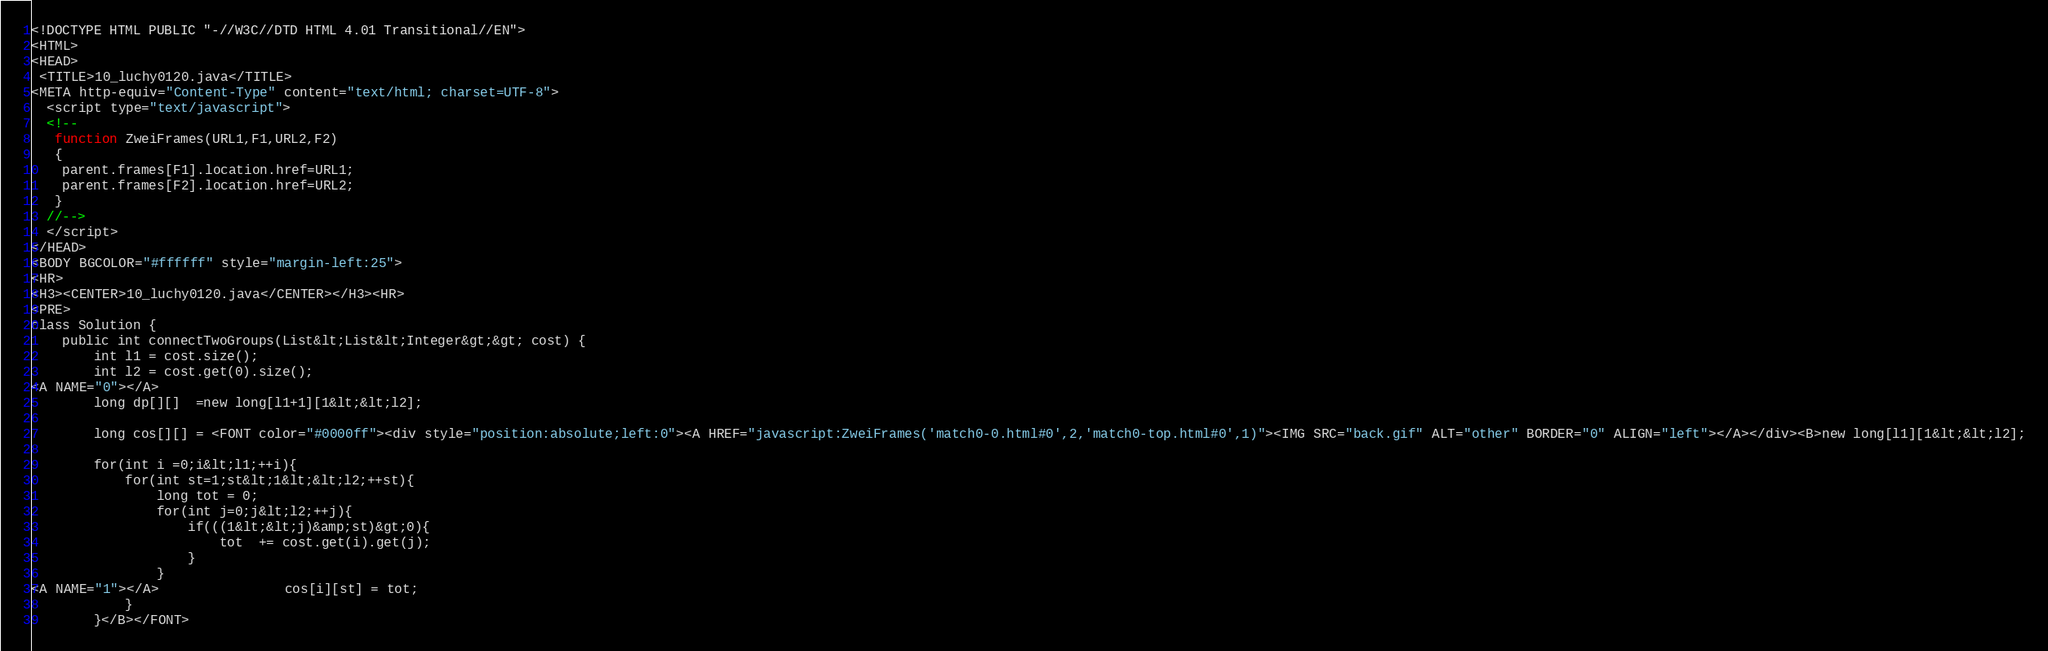Convert code to text. <code><loc_0><loc_0><loc_500><loc_500><_HTML_><!DOCTYPE HTML PUBLIC "-//W3C//DTD HTML 4.01 Transitional//EN">
<HTML>
<HEAD>
 <TITLE>10_luchy0120.java</TITLE>
<META http-equiv="Content-Type" content="text/html; charset=UTF-8">
  <script type="text/javascript">
  <!--
   function ZweiFrames(URL1,F1,URL2,F2)
   {
    parent.frames[F1].location.href=URL1;
    parent.frames[F2].location.href=URL2;
   }
  //-->
  </script>
</HEAD>
<BODY BGCOLOR="#ffffff" style="margin-left:25">
<HR>
<H3><CENTER>10_luchy0120.java</CENTER></H3><HR>
<PRE>
class Solution {
    public int connectTwoGroups(List&lt;List&lt;Integer&gt;&gt; cost) {
        int l1 = cost.size();
        int l2 = cost.get(0).size();
<A NAME="0"></A>        
        long dp[][]  =new long[l1+1][1&lt;&lt;l2];
        
        long cos[][] = <FONT color="#0000ff"><div style="position:absolute;left:0"><A HREF="javascript:ZweiFrames('match0-0.html#0',2,'match0-top.html#0',1)"><IMG SRC="back.gif" ALT="other" BORDER="0" ALIGN="left"></A></div><B>new long[l1][1&lt;&lt;l2];
        
        for(int i =0;i&lt;l1;++i){
            for(int st=1;st&lt;1&lt;&lt;l2;++st){
                long tot = 0;
                for(int j=0;j&lt;l2;++j){
                    if(((1&lt;&lt;j)&amp;st)&gt;0){
                        tot  += cost.get(i).get(j);
                    }
                }
<A NAME="1"></A>                cos[i][st] = tot;
            }
        }</B></FONT></code> 